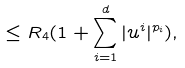Convert formula to latex. <formula><loc_0><loc_0><loc_500><loc_500>\leq R _ { 4 } ( 1 + \sum _ { i = 1 } ^ { d } | u ^ { i } | ^ { p _ { i } } ) ,</formula> 